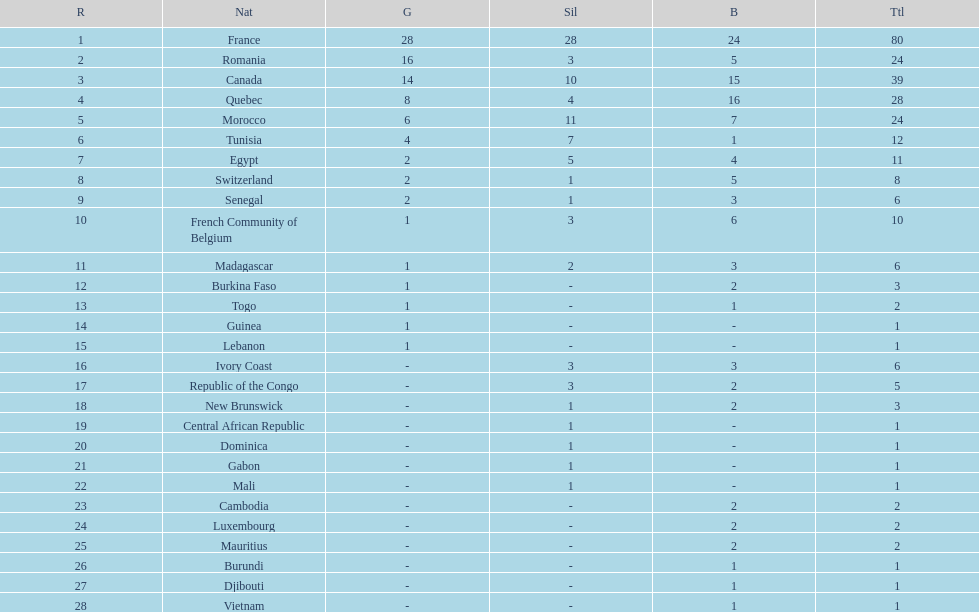What distinguishes the silver medals of france and egypt? 23. 